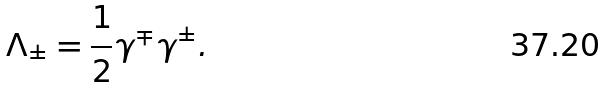Convert formula to latex. <formula><loc_0><loc_0><loc_500><loc_500>\Lambda _ { \pm } = \frac { 1 } { 2 } \gamma ^ { \mp } \gamma ^ { \pm } .</formula> 